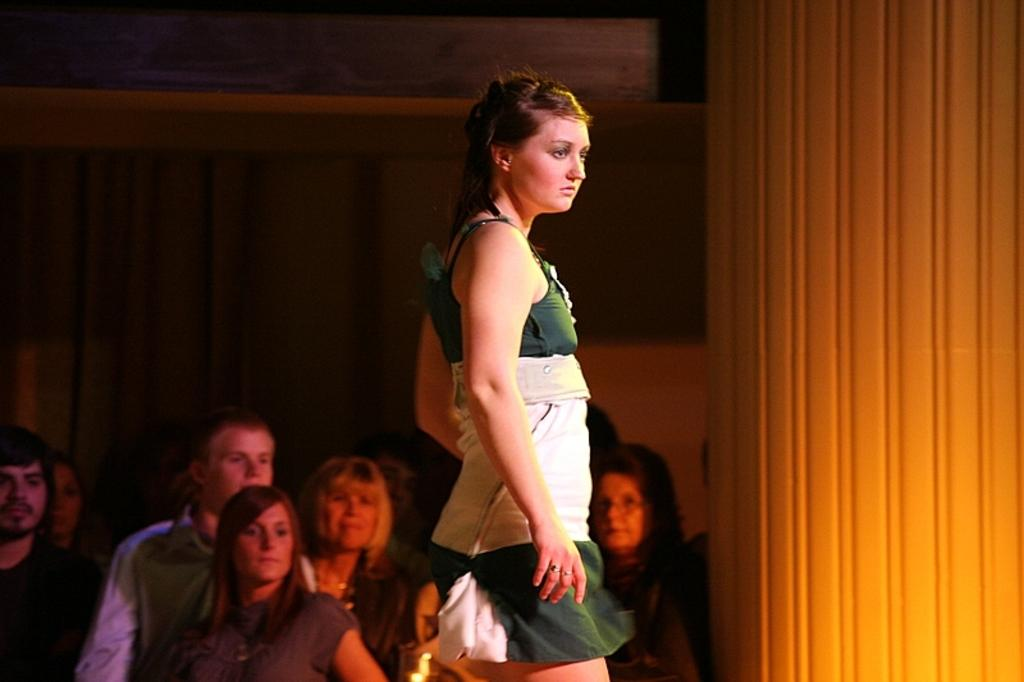What is the primary subject of the image? There is a woman standing in the image. What can be observed about the woman's attire? The woman is wearing clothes. Are there any other people in the image besides the woman? Yes, there are men and women in the image. What type of religious ceremony is taking place in the image? There is no indication of a religious ceremony in the image. Can you hear the woman laughing in the image? The image is a still photograph and does not contain any sound, so it is not possible to hear the woman laughing. 